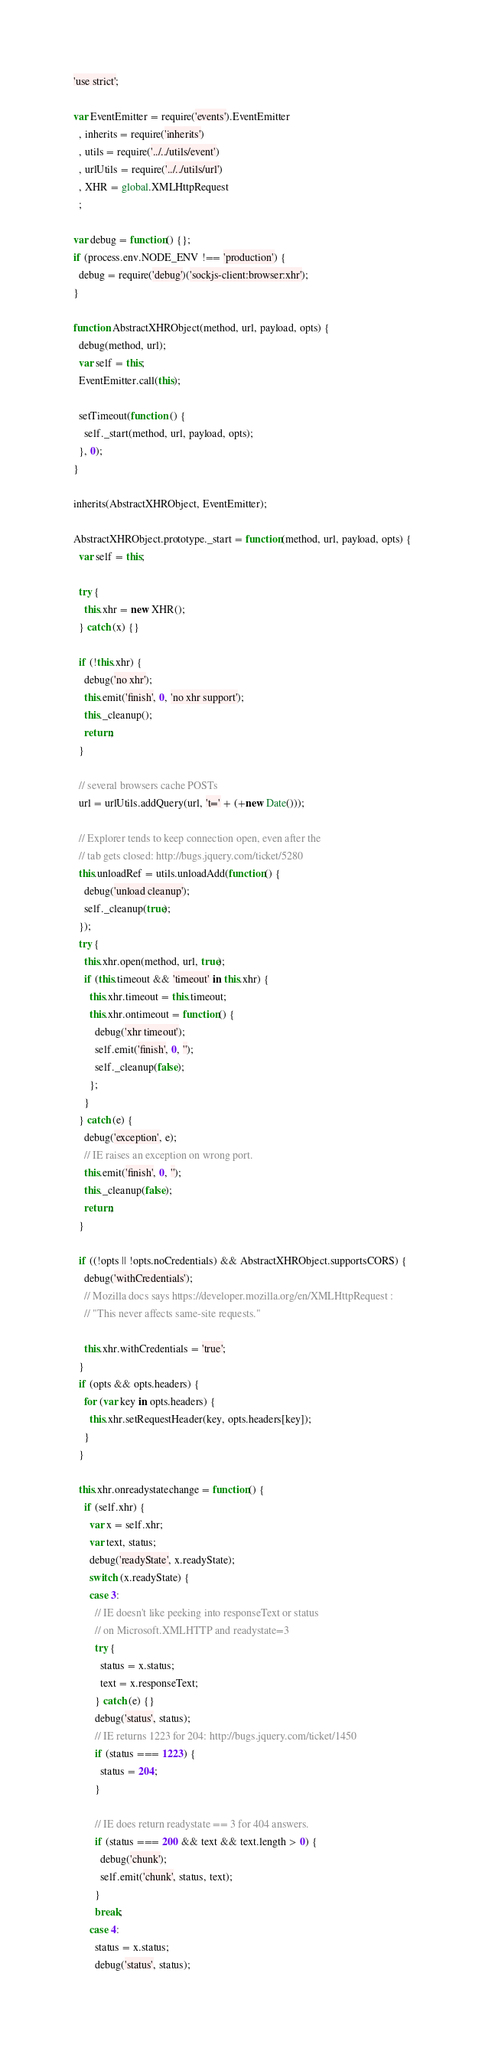<code> <loc_0><loc_0><loc_500><loc_500><_JavaScript_>'use strict';

var EventEmitter = require('events').EventEmitter
  , inherits = require('inherits')
  , utils = require('../../utils/event')
  , urlUtils = require('../../utils/url')
  , XHR = global.XMLHttpRequest
  ;

var debug = function() {};
if (process.env.NODE_ENV !== 'production') {
  debug = require('debug')('sockjs-client:browser:xhr');
}

function AbstractXHRObject(method, url, payload, opts) {
  debug(method, url);
  var self = this;
  EventEmitter.call(this);

  setTimeout(function () {
    self._start(method, url, payload, opts);
  }, 0);
}

inherits(AbstractXHRObject, EventEmitter);

AbstractXHRObject.prototype._start = function(method, url, payload, opts) {
  var self = this;

  try {
    this.xhr = new XHR();
  } catch (x) {}

  if (!this.xhr) {
    debug('no xhr');
    this.emit('finish', 0, 'no xhr support');
    this._cleanup();
    return;
  }

  // several browsers cache POSTs
  url = urlUtils.addQuery(url, 't=' + (+new Date()));

  // Explorer tends to keep connection open, even after the
  // tab gets closed: http://bugs.jquery.com/ticket/5280
  this.unloadRef = utils.unloadAdd(function() {
    debug('unload cleanup');
    self._cleanup(true);
  });
  try {
    this.xhr.open(method, url, true);
    if (this.timeout && 'timeout' in this.xhr) {
      this.xhr.timeout = this.timeout;
      this.xhr.ontimeout = function() {
        debug('xhr timeout');
        self.emit('finish', 0, '');
        self._cleanup(false);
      };
    }
  } catch (e) {
    debug('exception', e);
    // IE raises an exception on wrong port.
    this.emit('finish', 0, '');
    this._cleanup(false);
    return;
  }

  if ((!opts || !opts.noCredentials) && AbstractXHRObject.supportsCORS) {
    debug('withCredentials');
    // Mozilla docs says https://developer.mozilla.org/en/XMLHttpRequest :
    // "This never affects same-site requests."

    this.xhr.withCredentials = 'true';
  }
  if (opts && opts.headers) {
    for (var key in opts.headers) {
      this.xhr.setRequestHeader(key, opts.headers[key]);
    }
  }

  this.xhr.onreadystatechange = function() {
    if (self.xhr) {
      var x = self.xhr;
      var text, status;
      debug('readyState', x.readyState);
      switch (x.readyState) {
      case 3:
        // IE doesn't like peeking into responseText or status
        // on Microsoft.XMLHTTP and readystate=3
        try {
          status = x.status;
          text = x.responseText;
        } catch (e) {}
        debug('status', status);
        // IE returns 1223 for 204: http://bugs.jquery.com/ticket/1450
        if (status === 1223) {
          status = 204;
        }

        // IE does return readystate == 3 for 404 answers.
        if (status === 200 && text && text.length > 0) {
          debug('chunk');
          self.emit('chunk', status, text);
        }
        break;
      case 4:
        status = x.status;
        debug('status', status);</code> 